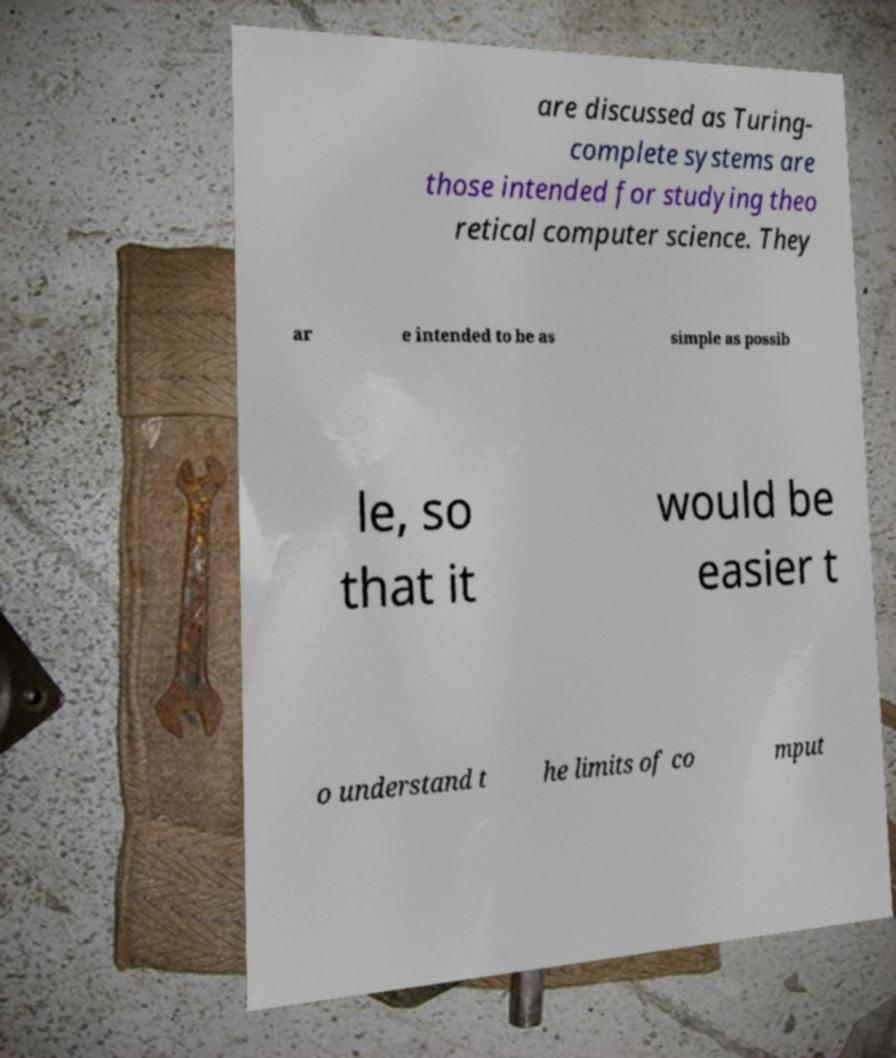There's text embedded in this image that I need extracted. Can you transcribe it verbatim? are discussed as Turing- complete systems are those intended for studying theo retical computer science. They ar e intended to be as simple as possib le, so that it would be easier t o understand t he limits of co mput 